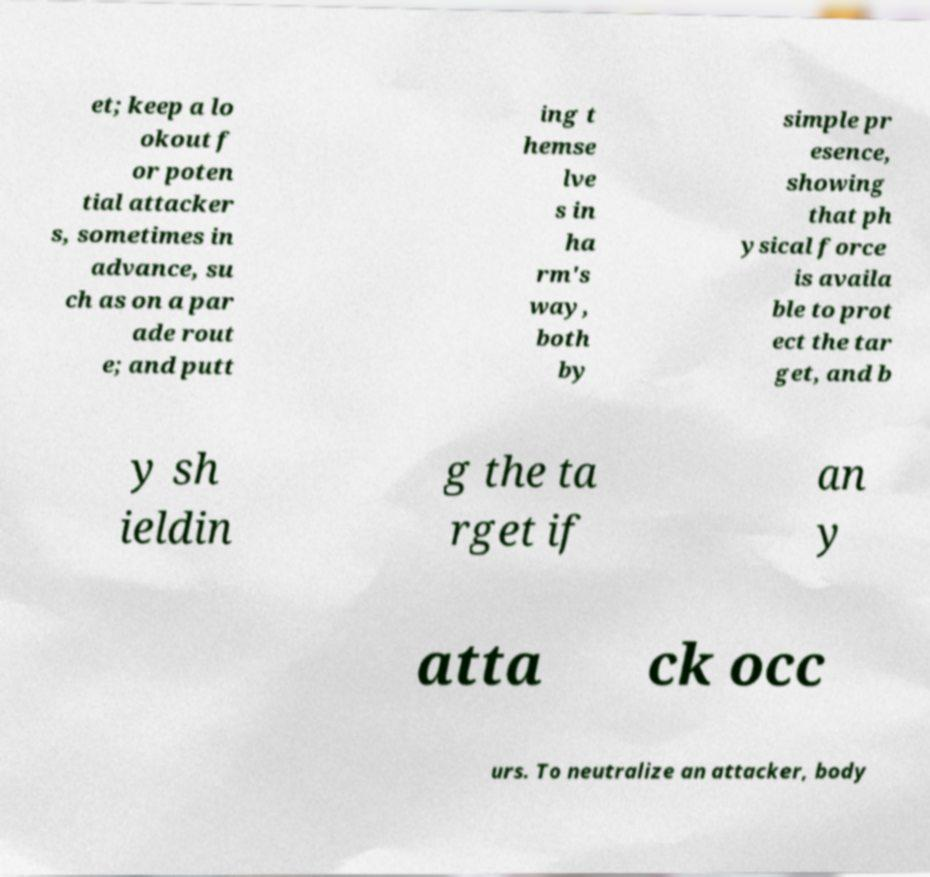What messages or text are displayed in this image? I need them in a readable, typed format. et; keep a lo okout f or poten tial attacker s, sometimes in advance, su ch as on a par ade rout e; and putt ing t hemse lve s in ha rm's way, both by simple pr esence, showing that ph ysical force is availa ble to prot ect the tar get, and b y sh ieldin g the ta rget if an y atta ck occ urs. To neutralize an attacker, body 